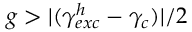Convert formula to latex. <formula><loc_0><loc_0><loc_500><loc_500>g > | ( \gamma _ { e x c } ^ { h } - \gamma _ { c } ) | / 2</formula> 